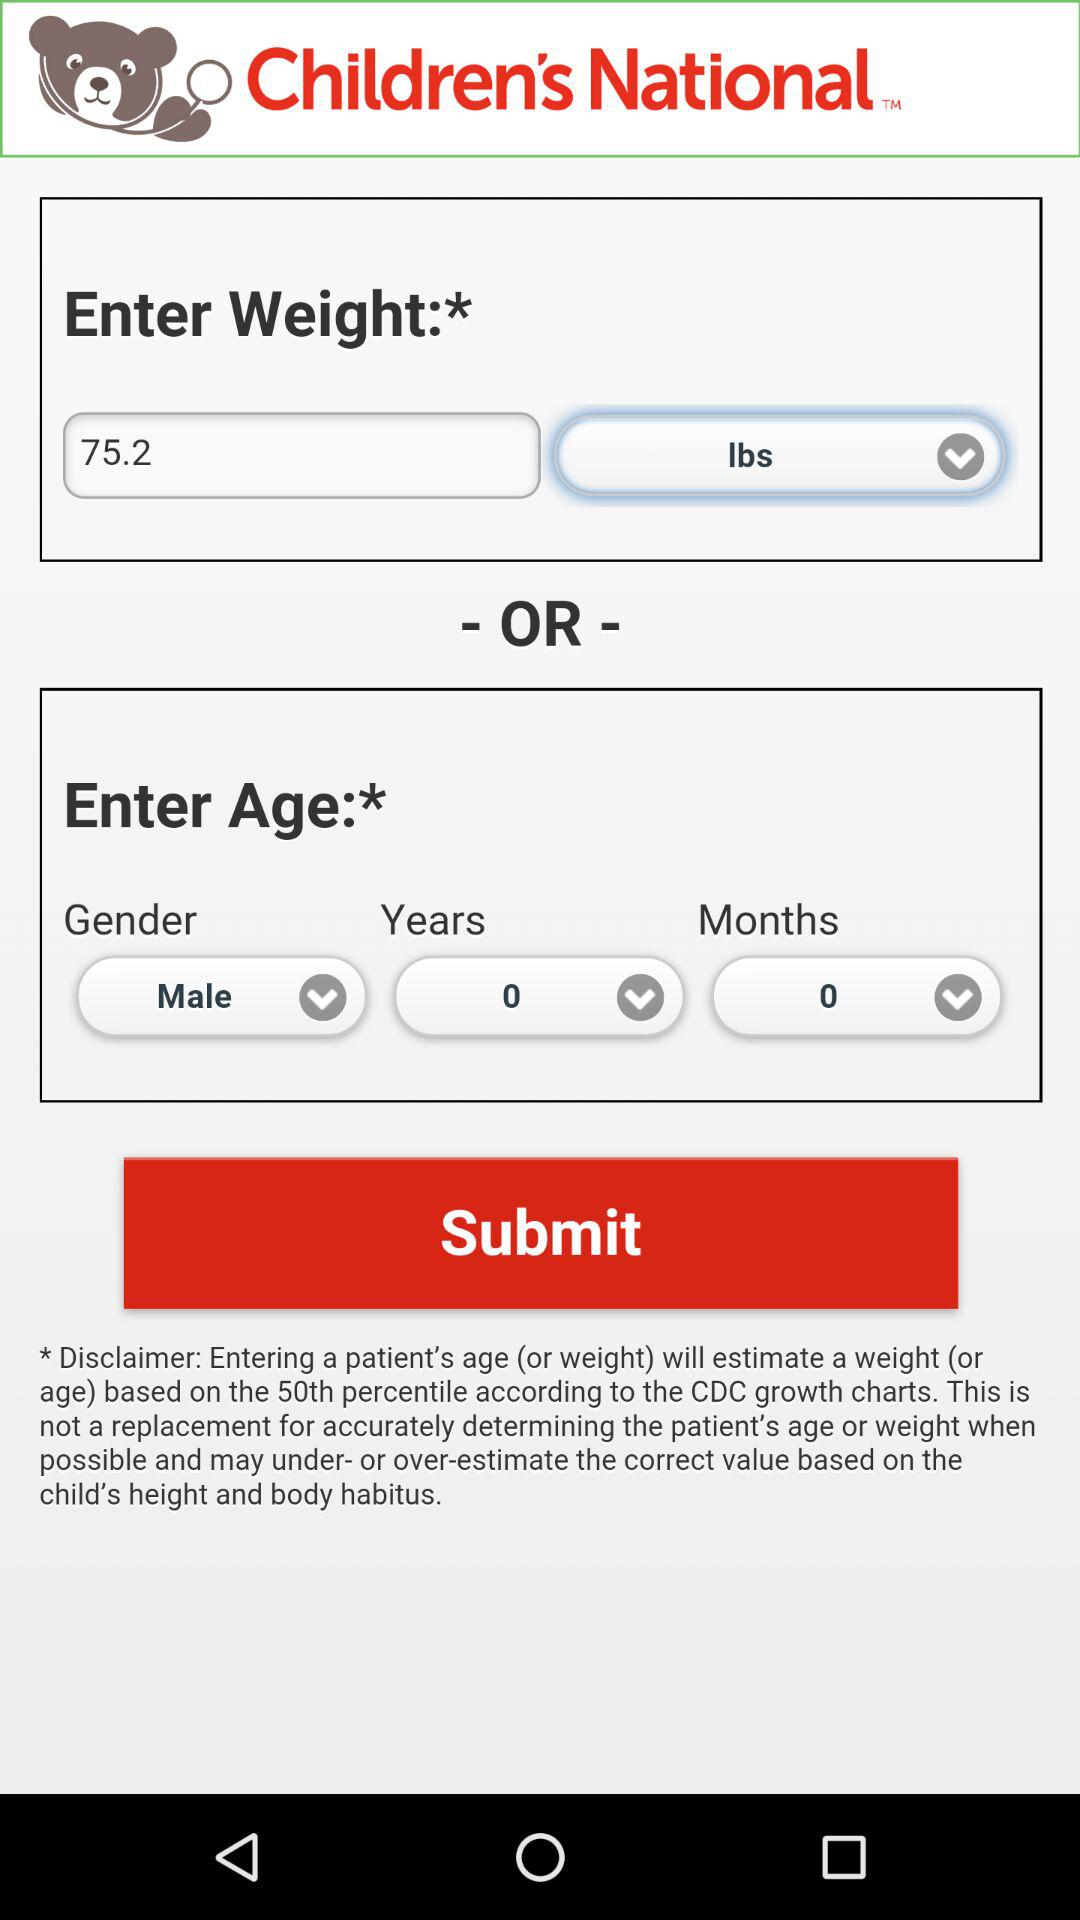How many years and months mentioned? There are 0 years and 0 months mentioned. 